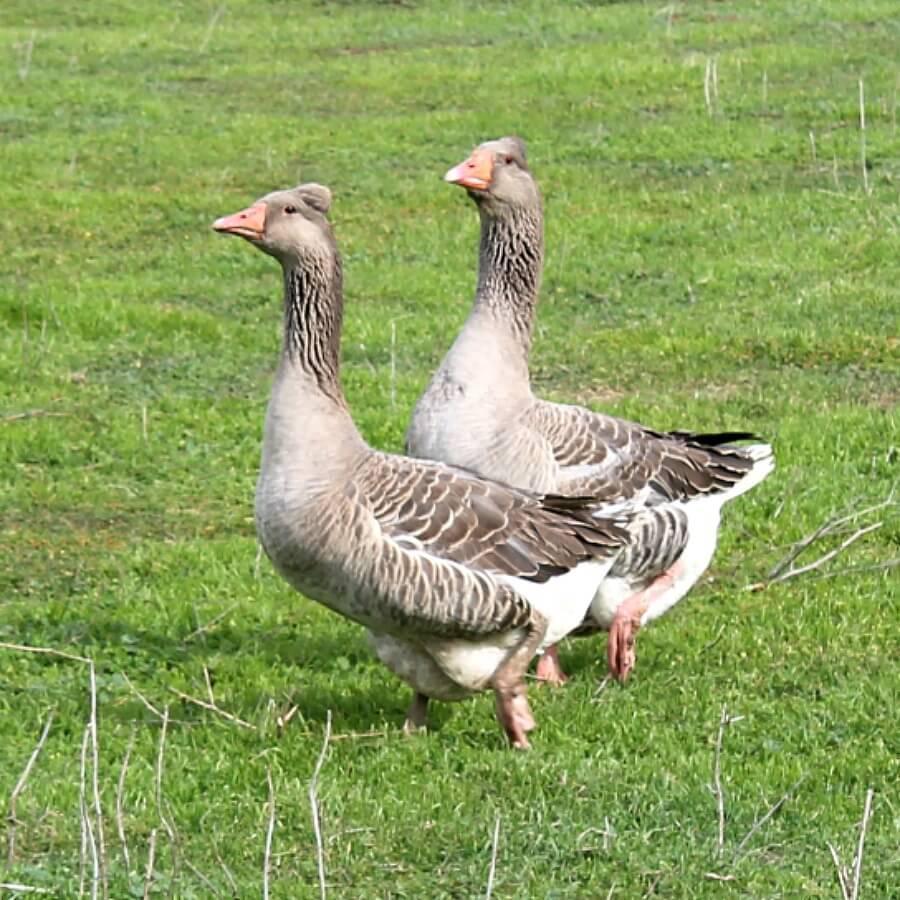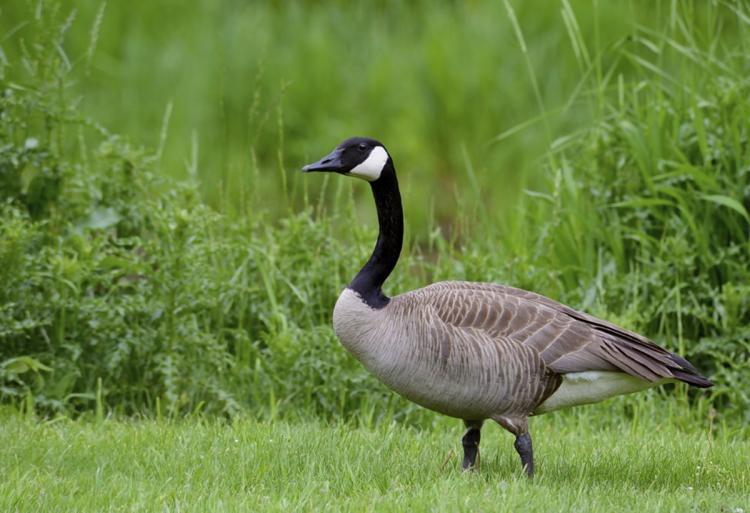The first image is the image on the left, the second image is the image on the right. Examine the images to the left and right. Is the description "All geese have black necks, and one image contains at least twice as many geese as the other image." accurate? Answer yes or no. No. The first image is the image on the left, the second image is the image on the right. Analyze the images presented: Is the assertion "The right image contains exactly one duck." valid? Answer yes or no. Yes. 